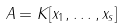<formula> <loc_0><loc_0><loc_500><loc_500>A = K [ x _ { 1 } , \dots , x _ { s } ]</formula> 